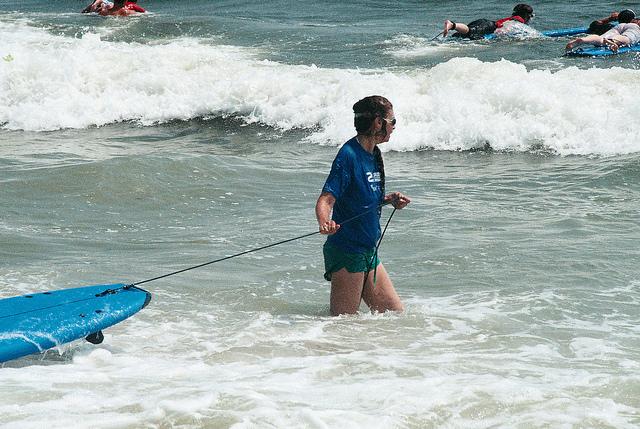What color is the board?
Answer briefly. Blue. What is she pulling?
Quick response, please. Surfboard. What is this person doing?
Answer briefly. Surfing. 